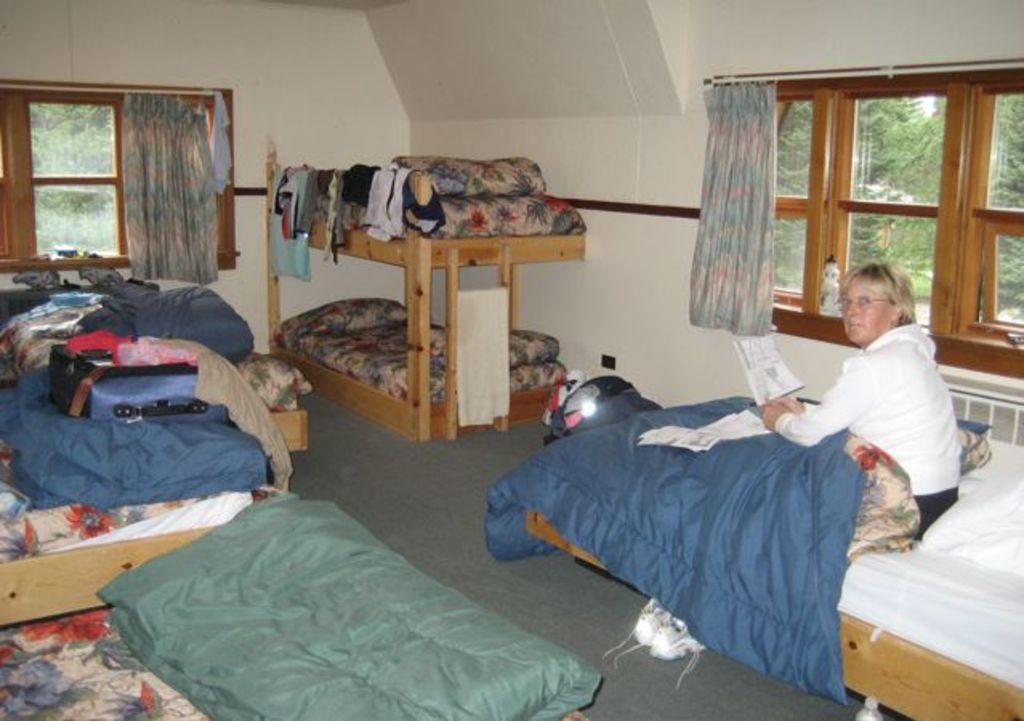In one or two sentences, can you explain what this image depicts? In the image it is a bedroom, there are few beds and on one of the bed there is a woman, she is holding some book and beside her there is a window and the room is very messy with the clothes and in the background there is a wall and in between the wall there is a window. 